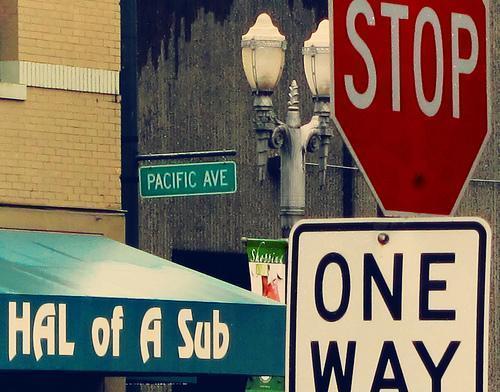How many stop signs are there?
Give a very brief answer. 1. 